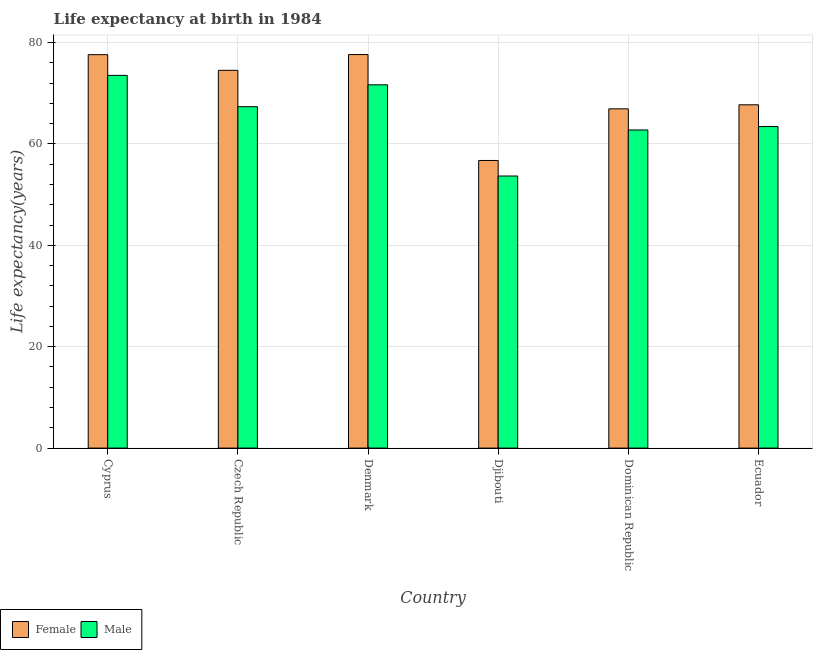How many different coloured bars are there?
Ensure brevity in your answer.  2. How many groups of bars are there?
Make the answer very short. 6. Are the number of bars on each tick of the X-axis equal?
Make the answer very short. Yes. How many bars are there on the 2nd tick from the left?
Your answer should be very brief. 2. How many bars are there on the 1st tick from the right?
Provide a succinct answer. 2. What is the label of the 6th group of bars from the left?
Keep it short and to the point. Ecuador. What is the life expectancy(female) in Dominican Republic?
Ensure brevity in your answer.  66.91. Across all countries, what is the maximum life expectancy(female)?
Your response must be concise. 77.62. Across all countries, what is the minimum life expectancy(female)?
Your answer should be compact. 56.73. In which country was the life expectancy(male) minimum?
Offer a very short reply. Djibouti. What is the total life expectancy(female) in the graph?
Provide a short and direct response. 421.08. What is the difference between the life expectancy(female) in Cyprus and that in Ecuador?
Offer a terse response. 9.89. What is the difference between the life expectancy(male) in Ecuador and the life expectancy(female) in Cyprus?
Provide a short and direct response. -14.18. What is the average life expectancy(male) per country?
Your answer should be very brief. 65.39. What is the difference between the life expectancy(male) and life expectancy(female) in Czech Republic?
Your response must be concise. -7.17. What is the ratio of the life expectancy(male) in Denmark to that in Djibouti?
Offer a terse response. 1.34. Is the life expectancy(female) in Djibouti less than that in Dominican Republic?
Keep it short and to the point. Yes. What is the difference between the highest and the second highest life expectancy(female)?
Offer a terse response. 0.02. What is the difference between the highest and the lowest life expectancy(female)?
Give a very brief answer. 20.89. How many bars are there?
Your answer should be very brief. 12. Are all the bars in the graph horizontal?
Your response must be concise. No. How many legend labels are there?
Your response must be concise. 2. What is the title of the graph?
Ensure brevity in your answer.  Life expectancy at birth in 1984. What is the label or title of the X-axis?
Ensure brevity in your answer.  Country. What is the label or title of the Y-axis?
Offer a terse response. Life expectancy(years). What is the Life expectancy(years) in Female in Cyprus?
Your answer should be compact. 77.6. What is the Life expectancy(years) in Male in Cyprus?
Keep it short and to the point. 73.52. What is the Life expectancy(years) of Female in Czech Republic?
Give a very brief answer. 74.51. What is the Life expectancy(years) of Male in Czech Republic?
Offer a very short reply. 67.34. What is the Life expectancy(years) of Female in Denmark?
Offer a terse response. 77.62. What is the Life expectancy(years) in Male in Denmark?
Offer a terse response. 71.65. What is the Life expectancy(years) in Female in Djibouti?
Your answer should be compact. 56.73. What is the Life expectancy(years) of Male in Djibouti?
Your answer should be very brief. 53.66. What is the Life expectancy(years) of Female in Dominican Republic?
Your answer should be compact. 66.91. What is the Life expectancy(years) in Male in Dominican Republic?
Your answer should be very brief. 62.74. What is the Life expectancy(years) in Female in Ecuador?
Ensure brevity in your answer.  67.71. What is the Life expectancy(years) of Male in Ecuador?
Give a very brief answer. 63.42. Across all countries, what is the maximum Life expectancy(years) in Female?
Offer a terse response. 77.62. Across all countries, what is the maximum Life expectancy(years) of Male?
Make the answer very short. 73.52. Across all countries, what is the minimum Life expectancy(years) of Female?
Give a very brief answer. 56.73. Across all countries, what is the minimum Life expectancy(years) of Male?
Your response must be concise. 53.66. What is the total Life expectancy(years) of Female in the graph?
Your answer should be very brief. 421.08. What is the total Life expectancy(years) in Male in the graph?
Your answer should be compact. 392.33. What is the difference between the Life expectancy(years) of Female in Cyprus and that in Czech Republic?
Your answer should be compact. 3.09. What is the difference between the Life expectancy(years) of Male in Cyprus and that in Czech Republic?
Keep it short and to the point. 6.17. What is the difference between the Life expectancy(years) in Female in Cyprus and that in Denmark?
Provide a short and direct response. -0.02. What is the difference between the Life expectancy(years) in Male in Cyprus and that in Denmark?
Keep it short and to the point. 1.86. What is the difference between the Life expectancy(years) in Female in Cyprus and that in Djibouti?
Provide a short and direct response. 20.87. What is the difference between the Life expectancy(years) of Male in Cyprus and that in Djibouti?
Your response must be concise. 19.85. What is the difference between the Life expectancy(years) in Female in Cyprus and that in Dominican Republic?
Your answer should be compact. 10.68. What is the difference between the Life expectancy(years) in Male in Cyprus and that in Dominican Republic?
Give a very brief answer. 10.77. What is the difference between the Life expectancy(years) in Female in Cyprus and that in Ecuador?
Provide a short and direct response. 9.89. What is the difference between the Life expectancy(years) in Male in Cyprus and that in Ecuador?
Provide a succinct answer. 10.1. What is the difference between the Life expectancy(years) in Female in Czech Republic and that in Denmark?
Offer a terse response. -3.11. What is the difference between the Life expectancy(years) in Male in Czech Republic and that in Denmark?
Your response must be concise. -4.31. What is the difference between the Life expectancy(years) in Female in Czech Republic and that in Djibouti?
Provide a short and direct response. 17.78. What is the difference between the Life expectancy(years) in Male in Czech Republic and that in Djibouti?
Provide a short and direct response. 13.68. What is the difference between the Life expectancy(years) of Female in Czech Republic and that in Dominican Republic?
Provide a succinct answer. 7.6. What is the difference between the Life expectancy(years) of Male in Czech Republic and that in Dominican Republic?
Provide a short and direct response. 4.6. What is the difference between the Life expectancy(years) of Female in Czech Republic and that in Ecuador?
Offer a terse response. 6.8. What is the difference between the Life expectancy(years) in Male in Czech Republic and that in Ecuador?
Provide a short and direct response. 3.92. What is the difference between the Life expectancy(years) in Female in Denmark and that in Djibouti?
Provide a succinct answer. 20.89. What is the difference between the Life expectancy(years) in Male in Denmark and that in Djibouti?
Provide a succinct answer. 17.99. What is the difference between the Life expectancy(years) in Female in Denmark and that in Dominican Republic?
Keep it short and to the point. 10.71. What is the difference between the Life expectancy(years) of Male in Denmark and that in Dominican Republic?
Your answer should be very brief. 8.91. What is the difference between the Life expectancy(years) of Female in Denmark and that in Ecuador?
Make the answer very short. 9.91. What is the difference between the Life expectancy(years) of Male in Denmark and that in Ecuador?
Offer a terse response. 8.23. What is the difference between the Life expectancy(years) of Female in Djibouti and that in Dominican Republic?
Your answer should be very brief. -10.19. What is the difference between the Life expectancy(years) of Male in Djibouti and that in Dominican Republic?
Provide a short and direct response. -9.08. What is the difference between the Life expectancy(years) in Female in Djibouti and that in Ecuador?
Your answer should be compact. -10.98. What is the difference between the Life expectancy(years) in Male in Djibouti and that in Ecuador?
Your answer should be compact. -9.76. What is the difference between the Life expectancy(years) in Female in Dominican Republic and that in Ecuador?
Give a very brief answer. -0.8. What is the difference between the Life expectancy(years) of Male in Dominican Republic and that in Ecuador?
Give a very brief answer. -0.68. What is the difference between the Life expectancy(years) of Female in Cyprus and the Life expectancy(years) of Male in Czech Republic?
Your response must be concise. 10.26. What is the difference between the Life expectancy(years) of Female in Cyprus and the Life expectancy(years) of Male in Denmark?
Provide a short and direct response. 5.95. What is the difference between the Life expectancy(years) in Female in Cyprus and the Life expectancy(years) in Male in Djibouti?
Your answer should be very brief. 23.93. What is the difference between the Life expectancy(years) of Female in Cyprus and the Life expectancy(years) of Male in Dominican Republic?
Your response must be concise. 14.85. What is the difference between the Life expectancy(years) in Female in Cyprus and the Life expectancy(years) in Male in Ecuador?
Provide a succinct answer. 14.18. What is the difference between the Life expectancy(years) of Female in Czech Republic and the Life expectancy(years) of Male in Denmark?
Provide a short and direct response. 2.86. What is the difference between the Life expectancy(years) of Female in Czech Republic and the Life expectancy(years) of Male in Djibouti?
Offer a terse response. 20.85. What is the difference between the Life expectancy(years) of Female in Czech Republic and the Life expectancy(years) of Male in Dominican Republic?
Your response must be concise. 11.77. What is the difference between the Life expectancy(years) of Female in Czech Republic and the Life expectancy(years) of Male in Ecuador?
Provide a succinct answer. 11.09. What is the difference between the Life expectancy(years) in Female in Denmark and the Life expectancy(years) in Male in Djibouti?
Ensure brevity in your answer.  23.96. What is the difference between the Life expectancy(years) of Female in Denmark and the Life expectancy(years) of Male in Dominican Republic?
Keep it short and to the point. 14.88. What is the difference between the Life expectancy(years) in Female in Djibouti and the Life expectancy(years) in Male in Dominican Republic?
Provide a succinct answer. -6.01. What is the difference between the Life expectancy(years) of Female in Djibouti and the Life expectancy(years) of Male in Ecuador?
Offer a terse response. -6.69. What is the difference between the Life expectancy(years) of Female in Dominican Republic and the Life expectancy(years) of Male in Ecuador?
Give a very brief answer. 3.49. What is the average Life expectancy(years) in Female per country?
Keep it short and to the point. 70.18. What is the average Life expectancy(years) in Male per country?
Provide a short and direct response. 65.39. What is the difference between the Life expectancy(years) in Female and Life expectancy(years) in Male in Cyprus?
Your answer should be very brief. 4.08. What is the difference between the Life expectancy(years) in Female and Life expectancy(years) in Male in Czech Republic?
Your answer should be compact. 7.17. What is the difference between the Life expectancy(years) of Female and Life expectancy(years) of Male in Denmark?
Offer a very short reply. 5.97. What is the difference between the Life expectancy(years) in Female and Life expectancy(years) in Male in Djibouti?
Your response must be concise. 3.06. What is the difference between the Life expectancy(years) in Female and Life expectancy(years) in Male in Dominican Republic?
Provide a succinct answer. 4.17. What is the difference between the Life expectancy(years) in Female and Life expectancy(years) in Male in Ecuador?
Offer a very short reply. 4.29. What is the ratio of the Life expectancy(years) of Female in Cyprus to that in Czech Republic?
Keep it short and to the point. 1.04. What is the ratio of the Life expectancy(years) of Male in Cyprus to that in Czech Republic?
Your answer should be compact. 1.09. What is the ratio of the Life expectancy(years) of Female in Cyprus to that in Djibouti?
Offer a very short reply. 1.37. What is the ratio of the Life expectancy(years) of Male in Cyprus to that in Djibouti?
Offer a very short reply. 1.37. What is the ratio of the Life expectancy(years) of Female in Cyprus to that in Dominican Republic?
Provide a short and direct response. 1.16. What is the ratio of the Life expectancy(years) in Male in Cyprus to that in Dominican Republic?
Your answer should be compact. 1.17. What is the ratio of the Life expectancy(years) of Female in Cyprus to that in Ecuador?
Offer a very short reply. 1.15. What is the ratio of the Life expectancy(years) in Male in Cyprus to that in Ecuador?
Provide a short and direct response. 1.16. What is the ratio of the Life expectancy(years) in Female in Czech Republic to that in Denmark?
Your answer should be compact. 0.96. What is the ratio of the Life expectancy(years) of Male in Czech Republic to that in Denmark?
Give a very brief answer. 0.94. What is the ratio of the Life expectancy(years) in Female in Czech Republic to that in Djibouti?
Your answer should be compact. 1.31. What is the ratio of the Life expectancy(years) of Male in Czech Republic to that in Djibouti?
Provide a short and direct response. 1.25. What is the ratio of the Life expectancy(years) in Female in Czech Republic to that in Dominican Republic?
Offer a terse response. 1.11. What is the ratio of the Life expectancy(years) of Male in Czech Republic to that in Dominican Republic?
Your response must be concise. 1.07. What is the ratio of the Life expectancy(years) in Female in Czech Republic to that in Ecuador?
Offer a terse response. 1.1. What is the ratio of the Life expectancy(years) of Male in Czech Republic to that in Ecuador?
Provide a short and direct response. 1.06. What is the ratio of the Life expectancy(years) in Female in Denmark to that in Djibouti?
Your answer should be very brief. 1.37. What is the ratio of the Life expectancy(years) in Male in Denmark to that in Djibouti?
Offer a very short reply. 1.34. What is the ratio of the Life expectancy(years) in Female in Denmark to that in Dominican Republic?
Your response must be concise. 1.16. What is the ratio of the Life expectancy(years) of Male in Denmark to that in Dominican Republic?
Give a very brief answer. 1.14. What is the ratio of the Life expectancy(years) in Female in Denmark to that in Ecuador?
Offer a very short reply. 1.15. What is the ratio of the Life expectancy(years) of Male in Denmark to that in Ecuador?
Your response must be concise. 1.13. What is the ratio of the Life expectancy(years) in Female in Djibouti to that in Dominican Republic?
Provide a succinct answer. 0.85. What is the ratio of the Life expectancy(years) of Male in Djibouti to that in Dominican Republic?
Provide a short and direct response. 0.86. What is the ratio of the Life expectancy(years) in Female in Djibouti to that in Ecuador?
Your answer should be very brief. 0.84. What is the ratio of the Life expectancy(years) of Male in Djibouti to that in Ecuador?
Ensure brevity in your answer.  0.85. What is the ratio of the Life expectancy(years) in Female in Dominican Republic to that in Ecuador?
Offer a terse response. 0.99. What is the ratio of the Life expectancy(years) in Male in Dominican Republic to that in Ecuador?
Ensure brevity in your answer.  0.99. What is the difference between the highest and the second highest Life expectancy(years) of Female?
Provide a succinct answer. 0.02. What is the difference between the highest and the second highest Life expectancy(years) in Male?
Provide a succinct answer. 1.86. What is the difference between the highest and the lowest Life expectancy(years) in Female?
Offer a very short reply. 20.89. What is the difference between the highest and the lowest Life expectancy(years) in Male?
Give a very brief answer. 19.85. 